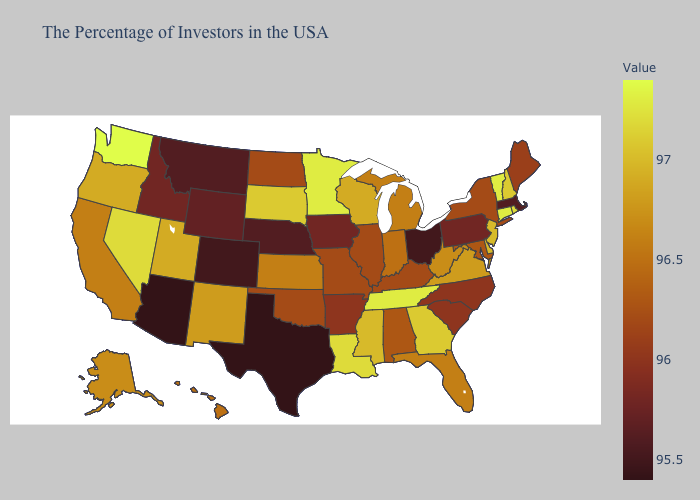Among the states that border Tennessee , which have the highest value?
Write a very short answer. Georgia. Does Ohio have the lowest value in the MidWest?
Keep it brief. Yes. Does Arizona have the lowest value in the USA?
Keep it brief. Yes. Does the map have missing data?
Concise answer only. No. Does Maryland have a higher value than Iowa?
Quick response, please. Yes. 